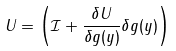<formula> <loc_0><loc_0><loc_500><loc_500>U = \left ( \mathcal { I } + \frac { \delta U } { \delta g ( y ) } \delta g ( y ) \right )</formula> 